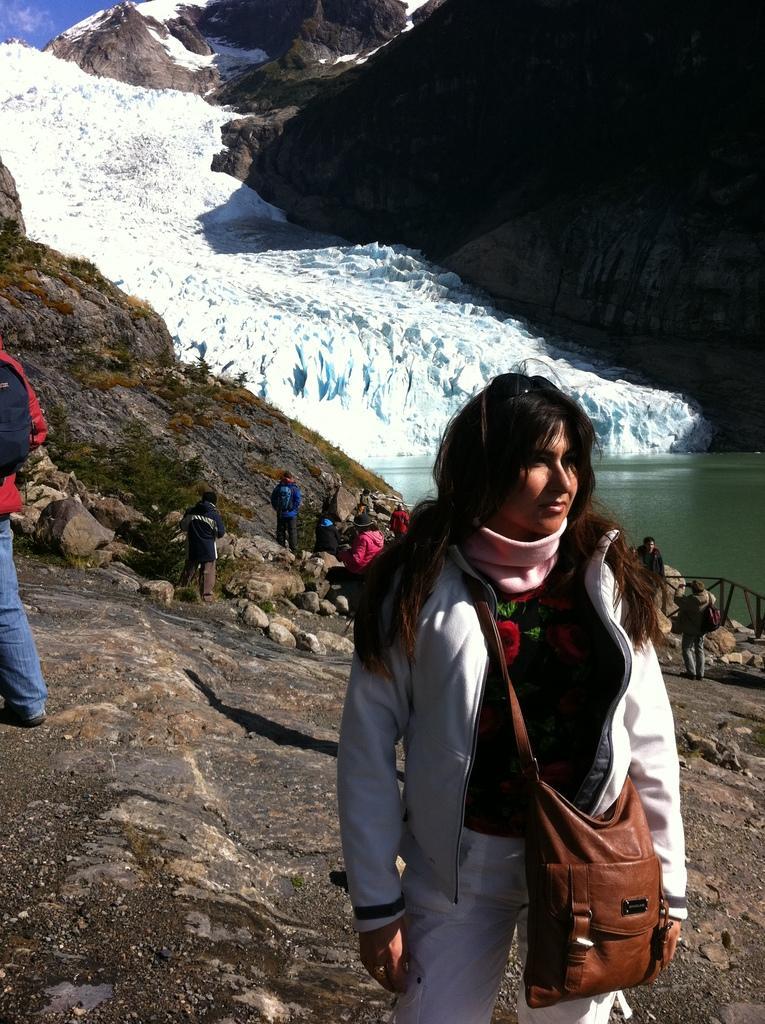Could you give a brief overview of what you see in this image? In this image there are people standing on rock mountains. In the foreground there is a woman standing. She is wearing a bag. To the right there is a railing. Beside the railing there is water on the ground. In the background there is ice on the mountains. At the top there is the sky. 